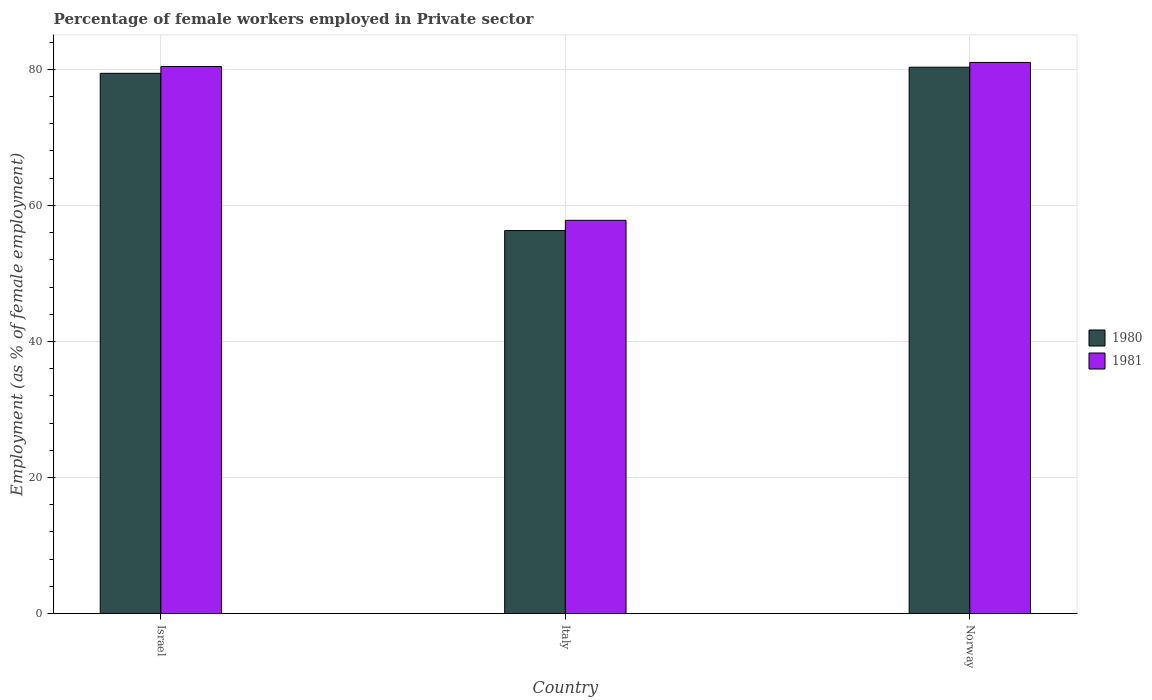How many groups of bars are there?
Ensure brevity in your answer.  3. How many bars are there on the 2nd tick from the left?
Provide a short and direct response. 2. How many bars are there on the 2nd tick from the right?
Keep it short and to the point. 2. What is the label of the 3rd group of bars from the left?
Provide a succinct answer. Norway. What is the percentage of females employed in Private sector in 1981 in Norway?
Ensure brevity in your answer.  81. Across all countries, what is the maximum percentage of females employed in Private sector in 1980?
Your response must be concise. 80.3. Across all countries, what is the minimum percentage of females employed in Private sector in 1980?
Keep it short and to the point. 56.3. In which country was the percentage of females employed in Private sector in 1981 minimum?
Provide a succinct answer. Italy. What is the total percentage of females employed in Private sector in 1981 in the graph?
Your answer should be compact. 219.2. What is the difference between the percentage of females employed in Private sector in 1981 in Israel and that in Italy?
Give a very brief answer. 22.6. What is the difference between the percentage of females employed in Private sector in 1980 in Italy and the percentage of females employed in Private sector in 1981 in Israel?
Offer a very short reply. -24.1. What is the average percentage of females employed in Private sector in 1980 per country?
Your answer should be compact. 72. What is the difference between the percentage of females employed in Private sector of/in 1981 and percentage of females employed in Private sector of/in 1980 in Italy?
Your answer should be compact. 1.5. In how many countries, is the percentage of females employed in Private sector in 1980 greater than 60 %?
Keep it short and to the point. 2. What is the ratio of the percentage of females employed in Private sector in 1980 in Israel to that in Italy?
Ensure brevity in your answer.  1.41. Is the percentage of females employed in Private sector in 1980 in Israel less than that in Italy?
Your answer should be very brief. No. What is the difference between the highest and the second highest percentage of females employed in Private sector in 1981?
Give a very brief answer. -0.6. What is the difference between the highest and the lowest percentage of females employed in Private sector in 1980?
Give a very brief answer. 24. Is the sum of the percentage of females employed in Private sector in 1981 in Israel and Italy greater than the maximum percentage of females employed in Private sector in 1980 across all countries?
Make the answer very short. Yes. What does the 2nd bar from the left in Italy represents?
Make the answer very short. 1981. How many bars are there?
Your answer should be very brief. 6. Are all the bars in the graph horizontal?
Keep it short and to the point. No. Does the graph contain any zero values?
Your response must be concise. No. Does the graph contain grids?
Your response must be concise. Yes. Where does the legend appear in the graph?
Your answer should be very brief. Center right. How many legend labels are there?
Keep it short and to the point. 2. How are the legend labels stacked?
Your answer should be compact. Vertical. What is the title of the graph?
Offer a terse response. Percentage of female workers employed in Private sector. Does "1965" appear as one of the legend labels in the graph?
Your response must be concise. No. What is the label or title of the X-axis?
Provide a short and direct response. Country. What is the label or title of the Y-axis?
Give a very brief answer. Employment (as % of female employment). What is the Employment (as % of female employment) in 1980 in Israel?
Provide a short and direct response. 79.4. What is the Employment (as % of female employment) of 1981 in Israel?
Your answer should be very brief. 80.4. What is the Employment (as % of female employment) of 1980 in Italy?
Give a very brief answer. 56.3. What is the Employment (as % of female employment) in 1981 in Italy?
Provide a short and direct response. 57.8. What is the Employment (as % of female employment) in 1980 in Norway?
Make the answer very short. 80.3. Across all countries, what is the maximum Employment (as % of female employment) in 1980?
Your response must be concise. 80.3. Across all countries, what is the minimum Employment (as % of female employment) of 1980?
Make the answer very short. 56.3. Across all countries, what is the minimum Employment (as % of female employment) of 1981?
Make the answer very short. 57.8. What is the total Employment (as % of female employment) of 1980 in the graph?
Your answer should be compact. 216. What is the total Employment (as % of female employment) of 1981 in the graph?
Ensure brevity in your answer.  219.2. What is the difference between the Employment (as % of female employment) of 1980 in Israel and that in Italy?
Make the answer very short. 23.1. What is the difference between the Employment (as % of female employment) of 1981 in Israel and that in Italy?
Make the answer very short. 22.6. What is the difference between the Employment (as % of female employment) of 1980 in Israel and that in Norway?
Make the answer very short. -0.9. What is the difference between the Employment (as % of female employment) of 1980 in Italy and that in Norway?
Your answer should be compact. -24. What is the difference between the Employment (as % of female employment) in 1981 in Italy and that in Norway?
Offer a very short reply. -23.2. What is the difference between the Employment (as % of female employment) in 1980 in Israel and the Employment (as % of female employment) in 1981 in Italy?
Your answer should be very brief. 21.6. What is the difference between the Employment (as % of female employment) of 1980 in Israel and the Employment (as % of female employment) of 1981 in Norway?
Keep it short and to the point. -1.6. What is the difference between the Employment (as % of female employment) of 1980 in Italy and the Employment (as % of female employment) of 1981 in Norway?
Your answer should be compact. -24.7. What is the average Employment (as % of female employment) of 1980 per country?
Provide a succinct answer. 72. What is the average Employment (as % of female employment) in 1981 per country?
Make the answer very short. 73.07. What is the difference between the Employment (as % of female employment) in 1980 and Employment (as % of female employment) in 1981 in Israel?
Make the answer very short. -1. What is the ratio of the Employment (as % of female employment) in 1980 in Israel to that in Italy?
Provide a short and direct response. 1.41. What is the ratio of the Employment (as % of female employment) in 1981 in Israel to that in Italy?
Your answer should be very brief. 1.39. What is the ratio of the Employment (as % of female employment) in 1980 in Italy to that in Norway?
Your answer should be compact. 0.7. What is the ratio of the Employment (as % of female employment) of 1981 in Italy to that in Norway?
Make the answer very short. 0.71. What is the difference between the highest and the second highest Employment (as % of female employment) in 1981?
Make the answer very short. 0.6. What is the difference between the highest and the lowest Employment (as % of female employment) of 1980?
Make the answer very short. 24. What is the difference between the highest and the lowest Employment (as % of female employment) of 1981?
Provide a short and direct response. 23.2. 